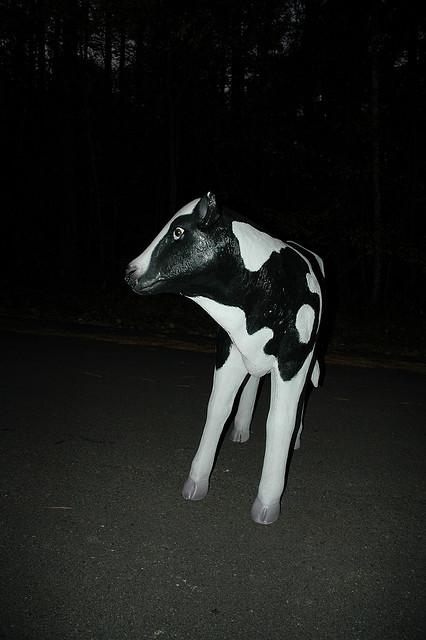Is this a real cow?
Concise answer only. No. Is anyone holding the cow?
Answer briefly. No. What animal is this?
Quick response, please. Cow. Was the picture taken indoors?
Short answer required. No. 